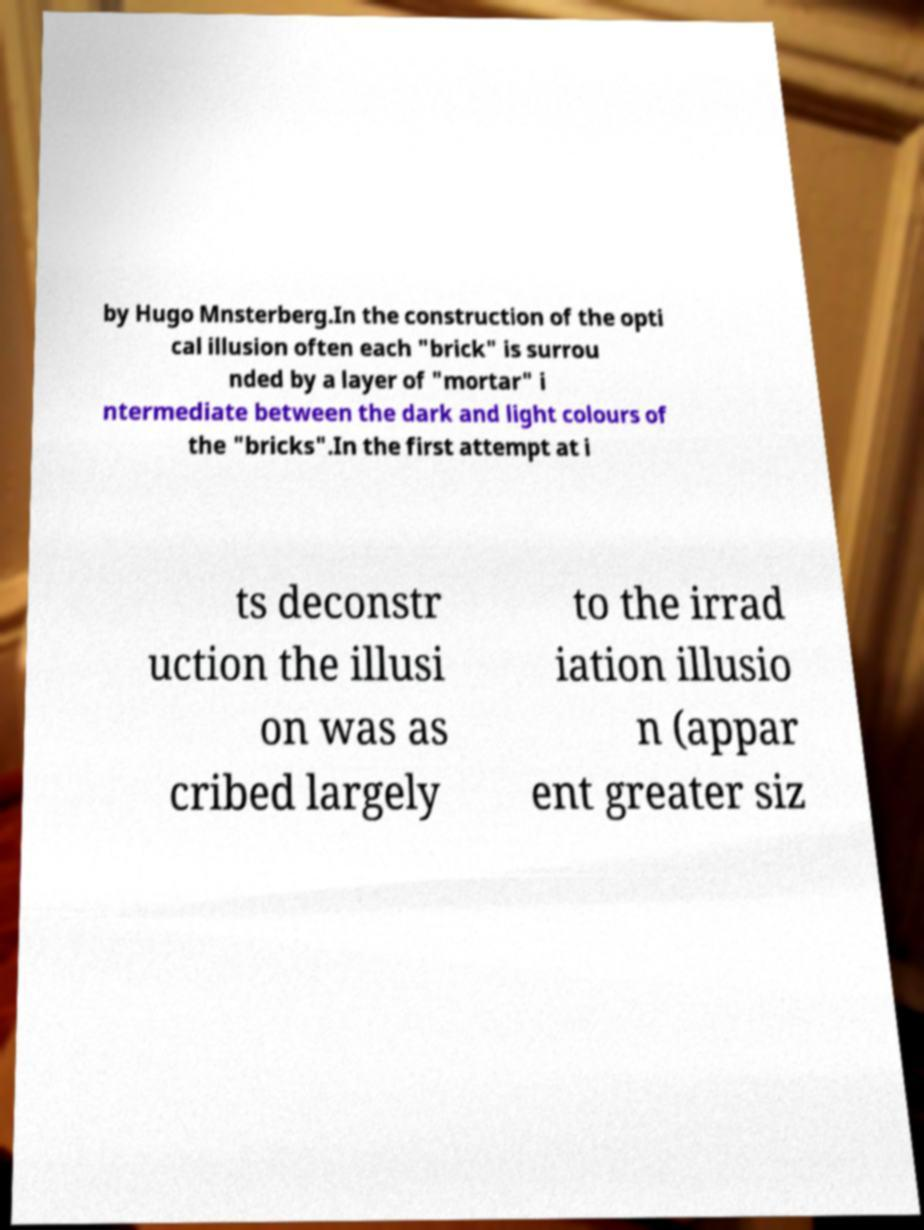Please read and relay the text visible in this image. What does it say? by Hugo Mnsterberg.In the construction of the opti cal illusion often each "brick" is surrou nded by a layer of "mortar" i ntermediate between the dark and light colours of the "bricks".In the first attempt at i ts deconstr uction the illusi on was as cribed largely to the irrad iation illusio n (appar ent greater siz 